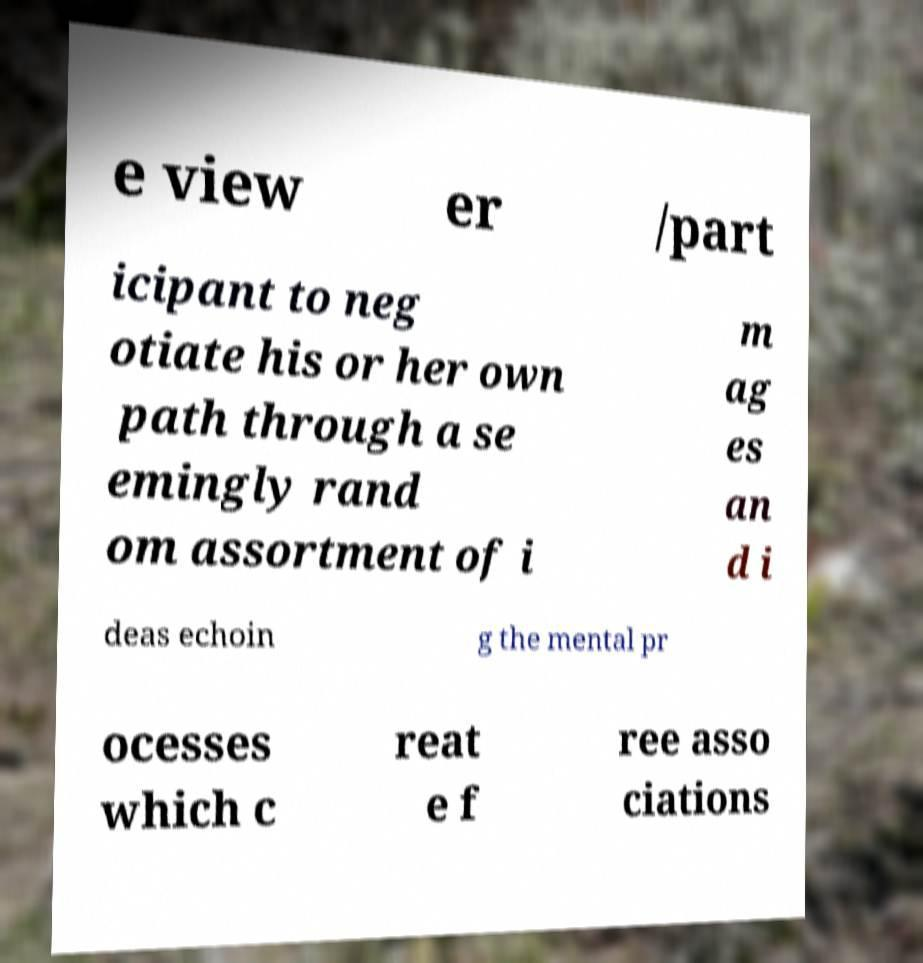Please identify and transcribe the text found in this image. e view er /part icipant to neg otiate his or her own path through a se emingly rand om assortment of i m ag es an d i deas echoin g the mental pr ocesses which c reat e f ree asso ciations 